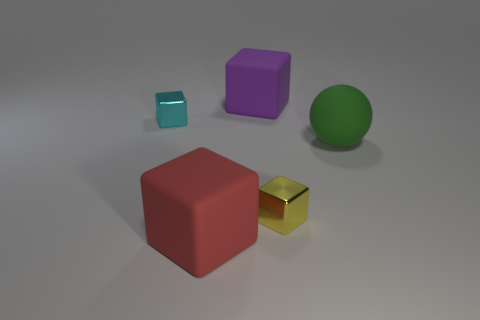What textures are visible on the objects in the image? The objects display various textures: the red cube appears to have a soft rubber-like texture; the golden cube has a shiny metallic finish; the green sphere seems to possess a smooth, matte surface; the purple cube also presents a matte finish; and the smaller turquoise cube has a transparent, glass-like texture. 